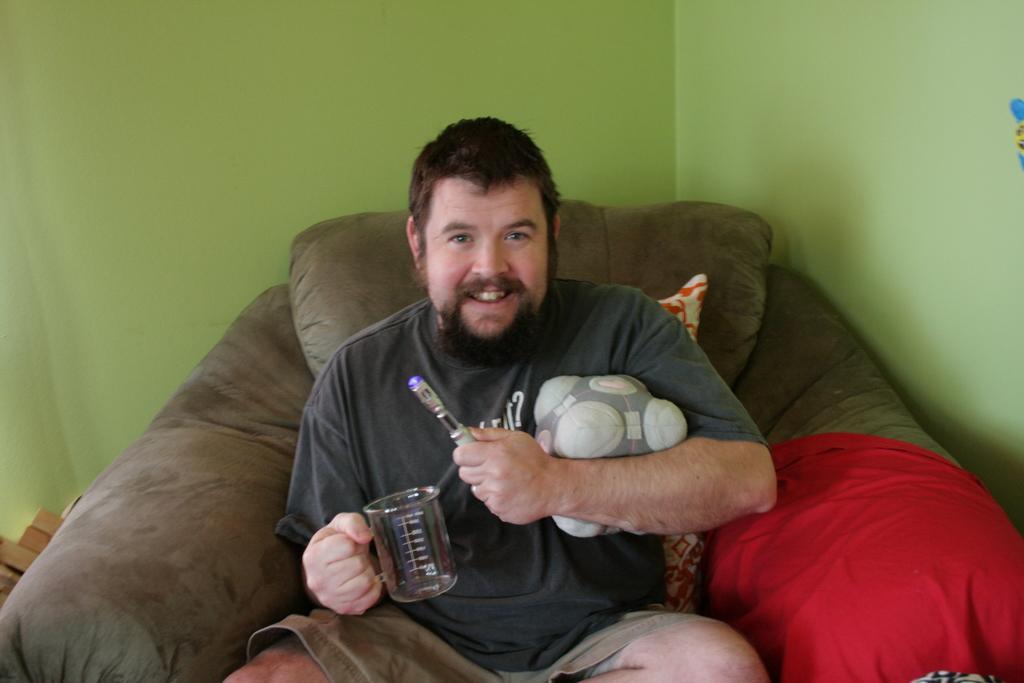In one or two sentences, can you explain what this image depicts? In the image there is a man sitting on a recliner and holding a glass, behind him there is wall. 